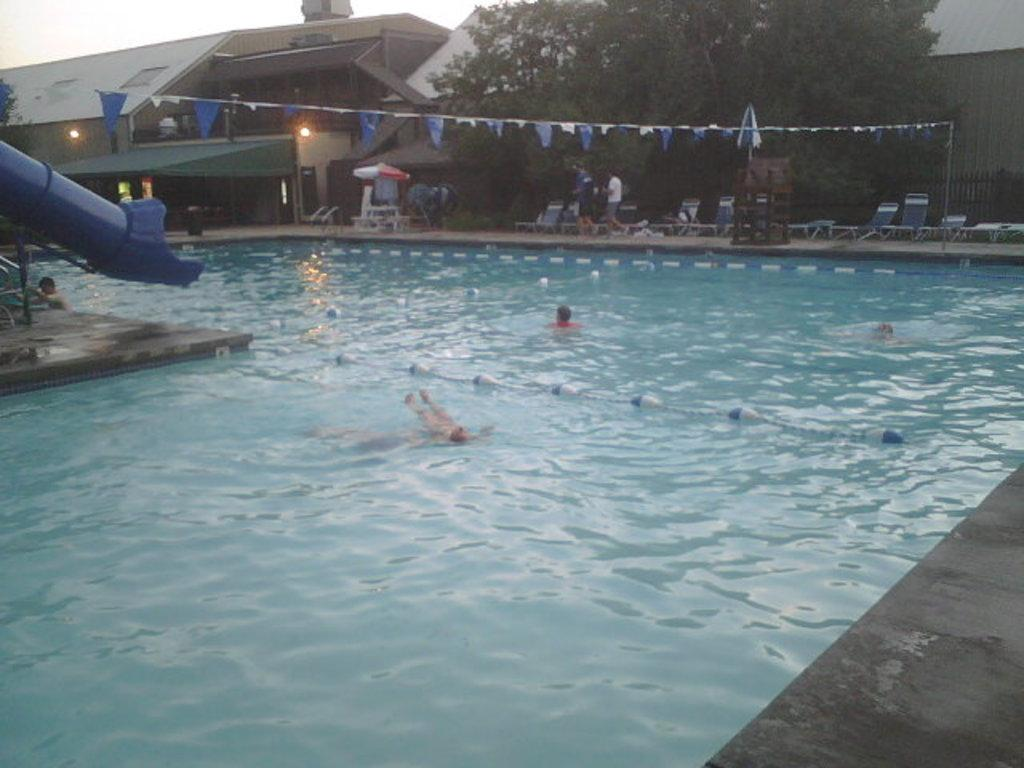What are the people in the image doing? The persons in the image are in a swimming pool. What can be seen in the background of the image? There are small flags on a rope, trees, sheds, and chairs in the background. How many different elements can be seen in the background? There are four different elements in the background: small flags on a rope, trees, sheds, and chairs. What type of insect can be seen flying over the swimming pool in the image? There is no insect visible in the image. How many trains are passing by in the background of the image? There are no trains present in the image. 